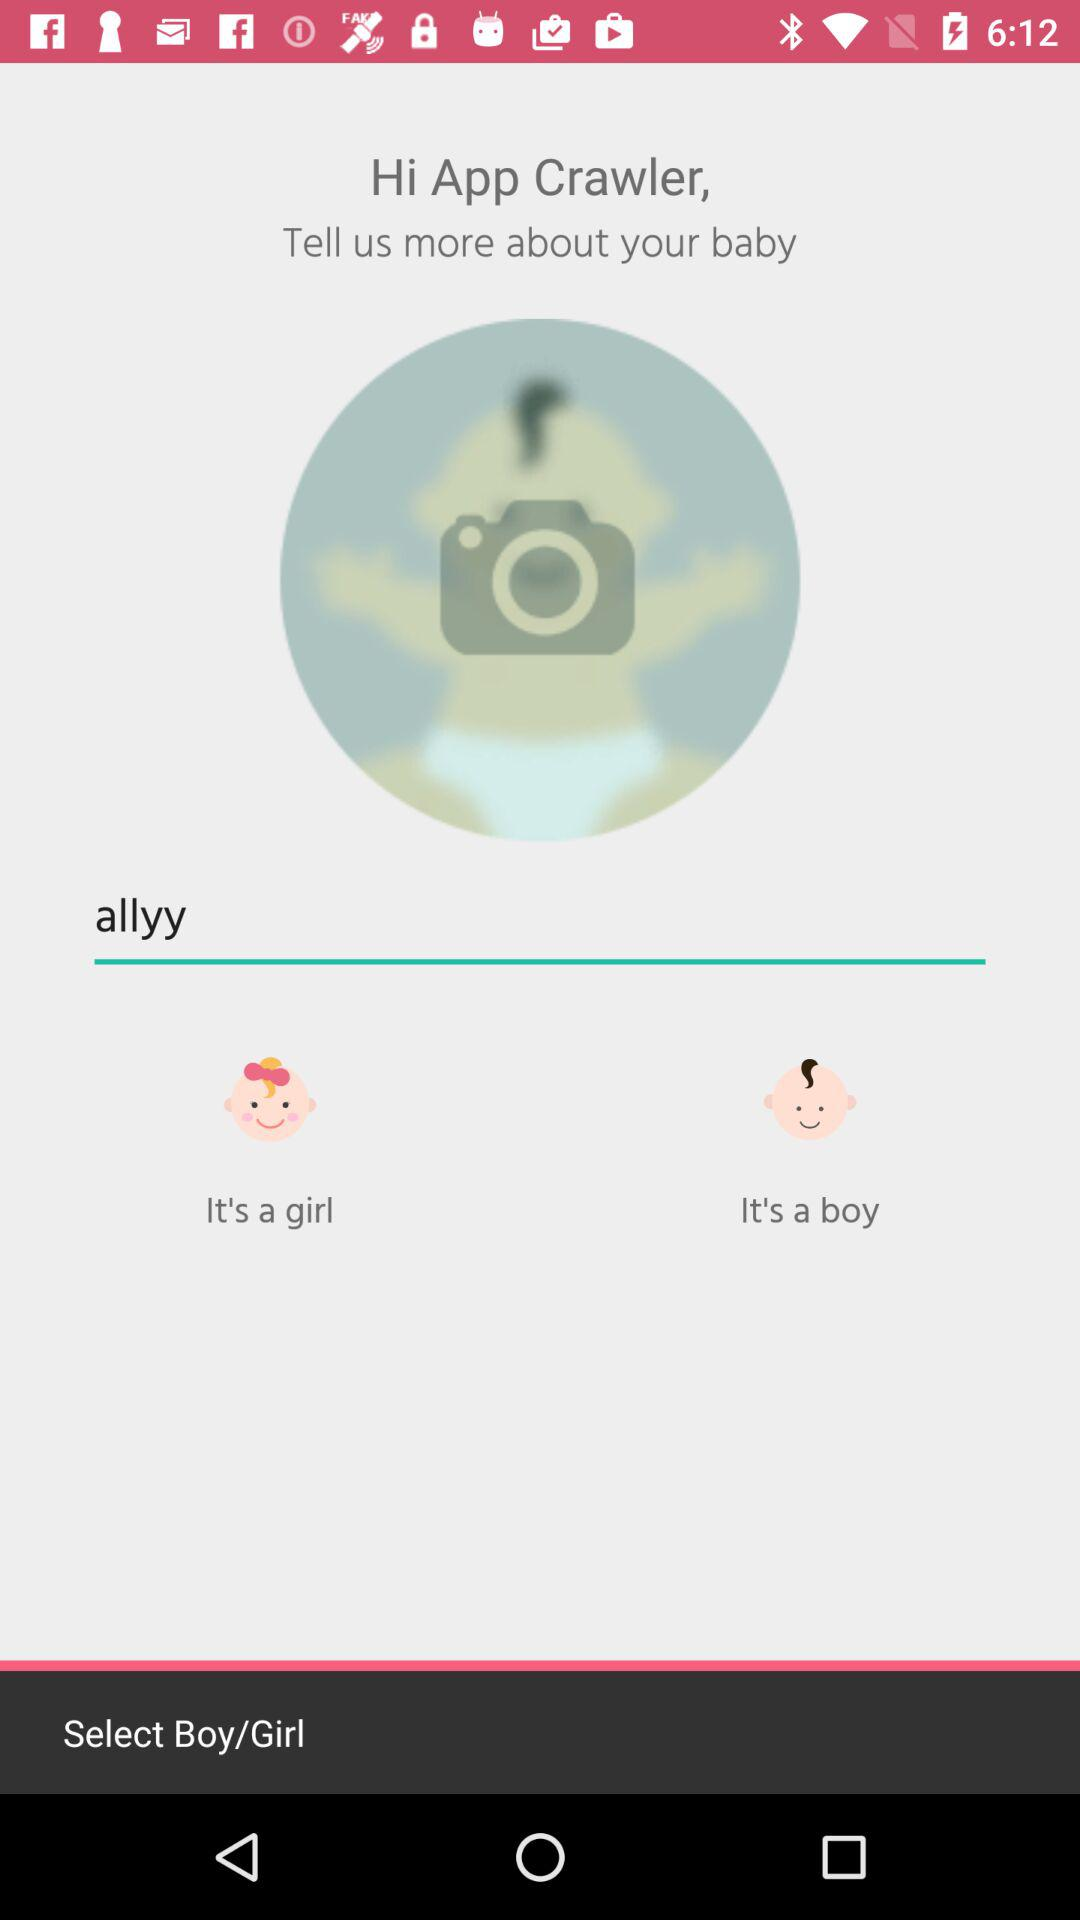What is the name of the baby? The name of the baby is Allyy. 